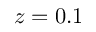<formula> <loc_0><loc_0><loc_500><loc_500>z = 0 . 1</formula> 